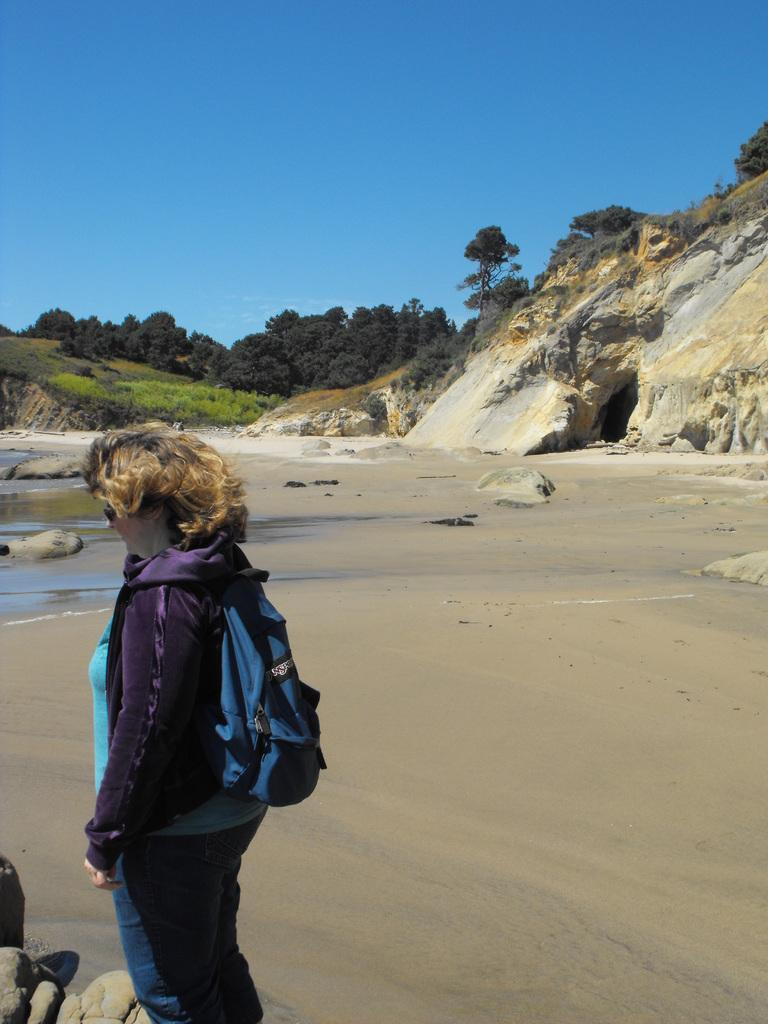Who is the main subject in the foreground of the image? There is a woman in the foreground of the image. What type of surface is the woman standing on? The woman is standing on a sand surface. What can be seen in the background of the image? There are steep mountains and trees. Is the sand in the image actually quicksand that the woman is standing on? No, the sand in the image is not quicksand; it is a regular sand surface. What type of lumber is being harvested from the trees in the background of the image? There is no lumber harvesting or any indication of lumber in the image; it only shows the woman standing on a sand surface and the background with steep mountains and trees. 